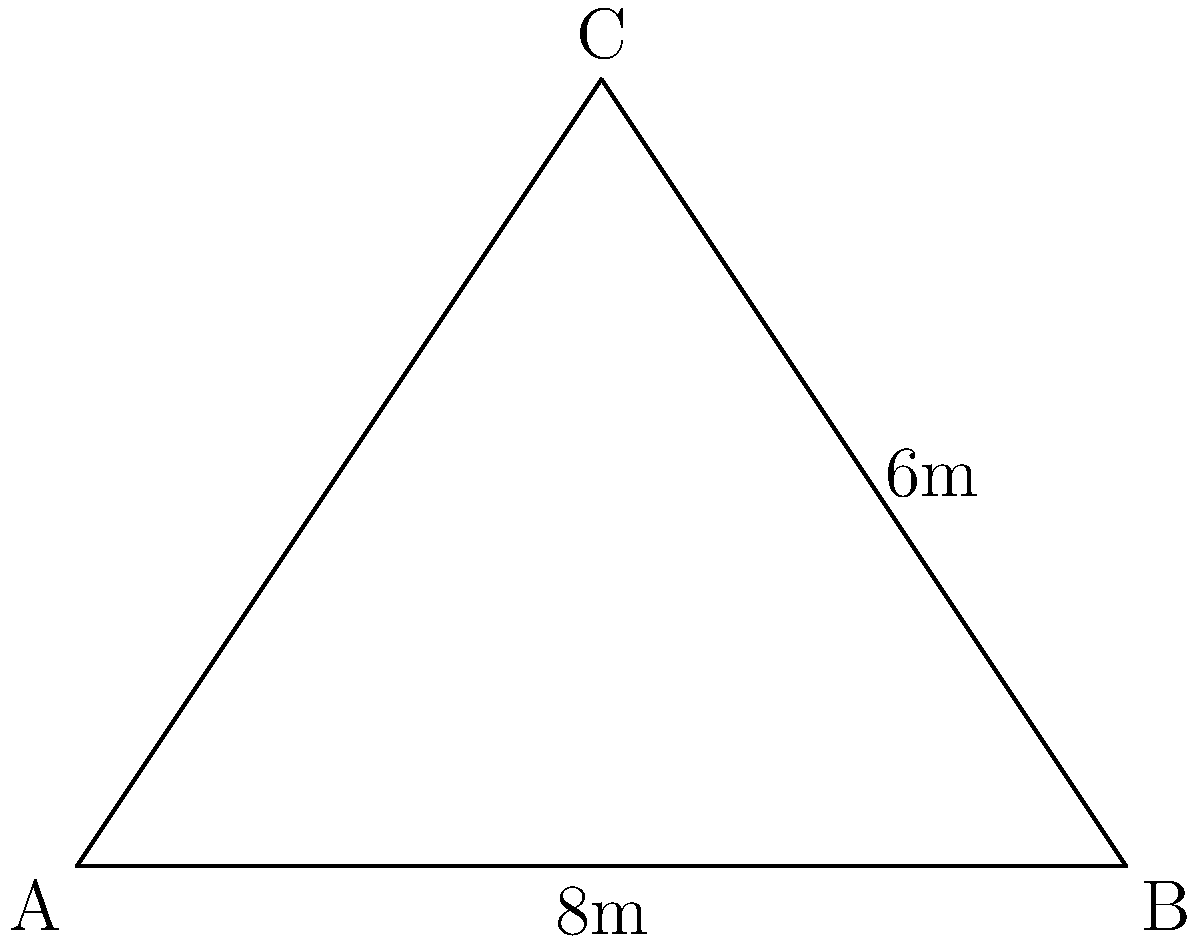A traditional Bosnian house has a steep roof with the following dimensions: the base width is 8 meters, and the height from the base to the peak is 6 meters. Calculate the slope angle $\theta$ of the roof and determine its orientation relative to the cardinal directions if the roof ridge runs from east to west. To solve this problem, we'll follow these steps:

1) First, we need to calculate the slope angle $\theta$. We can do this using the tangent function, as we have a right triangle formed by half of the roof.

2) The base of this triangle is half the width of the roof: $\frac{8}{2} = 4$ meters.

3) The height of the triangle is the full height of the roof: 6 meters.

4) The tangent of the angle $\theta$ is the ratio of the opposite side (height) to the adjacent side (half-base):

   $$\tan \theta = \frac{\text{opposite}}{\text{adjacent}} = \frac{6}{4} = 1.5$$

5) To find $\theta$, we need to take the inverse tangent (arctangent):

   $$\theta = \arctan(1.5) \approx 56.3^\circ$$

6) The slope can also be expressed as a percentage: $\frac{6}{4} \times 100\% = 150\%$

7) Regarding orientation, if the roof ridge runs from east to west, then the slope faces would be oriented north and south. The steeper side of traditional Bosnian roofs typically faces north to protect against harsh winter winds and maximize southern sun exposure.
Answer: Slope angle: $56.3^\circ$ or 150%. Orientation: North-facing and South-facing slopes. 